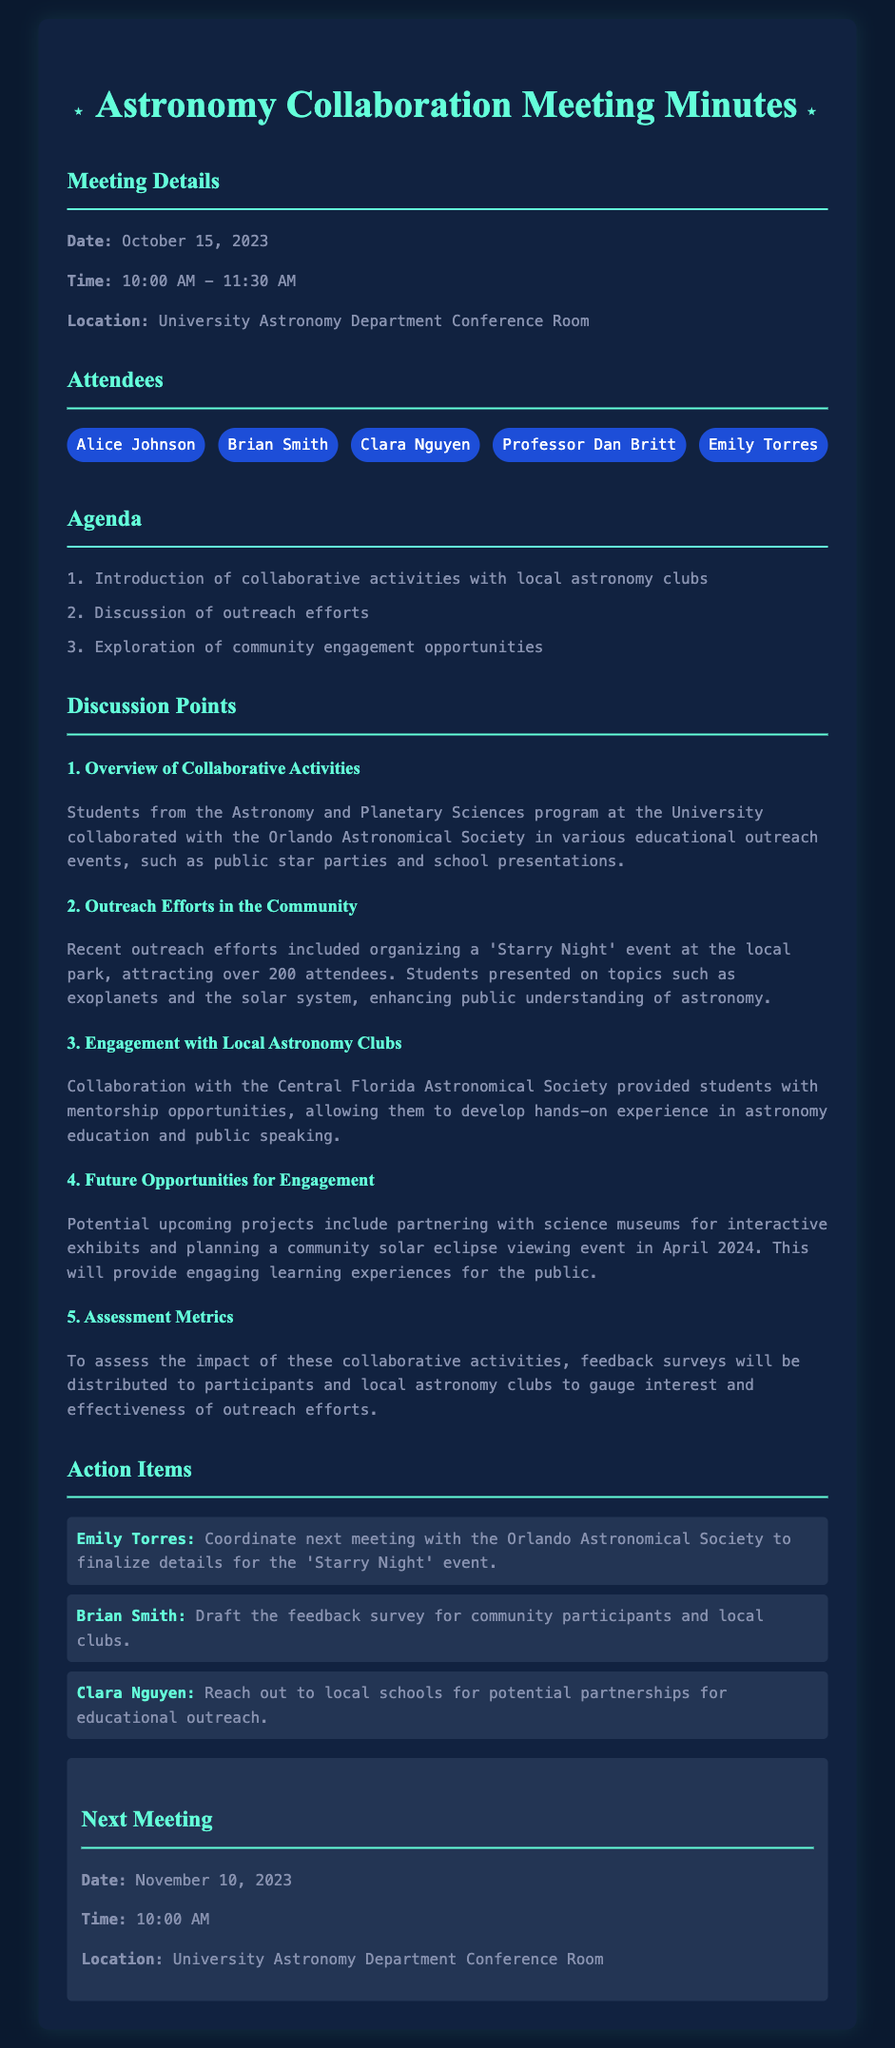what is the date of the meeting? The meeting date is explicitly stated in the document as October 15, 2023.
Answer: October 15, 2023 who presented on topics such as exoplanets and the solar system? Students presented on these topics during the 'Starry Night' event as mentioned in the outreach efforts section.
Answer: Students what was the attendance at the recent outreach event? The document mentions that over 200 attendees participated in the 'Starry Night' event.
Answer: over 200 what future event is planned for April 2024? The document specifies a community solar eclipse viewing event as a potential upcoming project for April 2024.
Answer: community solar eclipse viewing who is responsible for coordinating the next meeting? Emily Torres's action item includes coordinating the next meeting with the Orlando Astronomical Society.
Answer: Emily Torres what organization collaborated with the university students for various educational outreach events? The document identifies the Orlando Astronomical Society as the collaborating organization.
Answer: Orlando Astronomical Society how will the impact of the collaborative activities be assessed? The impact will be assessed by distributing feedback surveys to participants and local astronomy clubs.
Answer: feedback surveys when is the next meeting scheduled? The next meeting date is outlined in the document as November 10, 2023.
Answer: November 10, 2023 